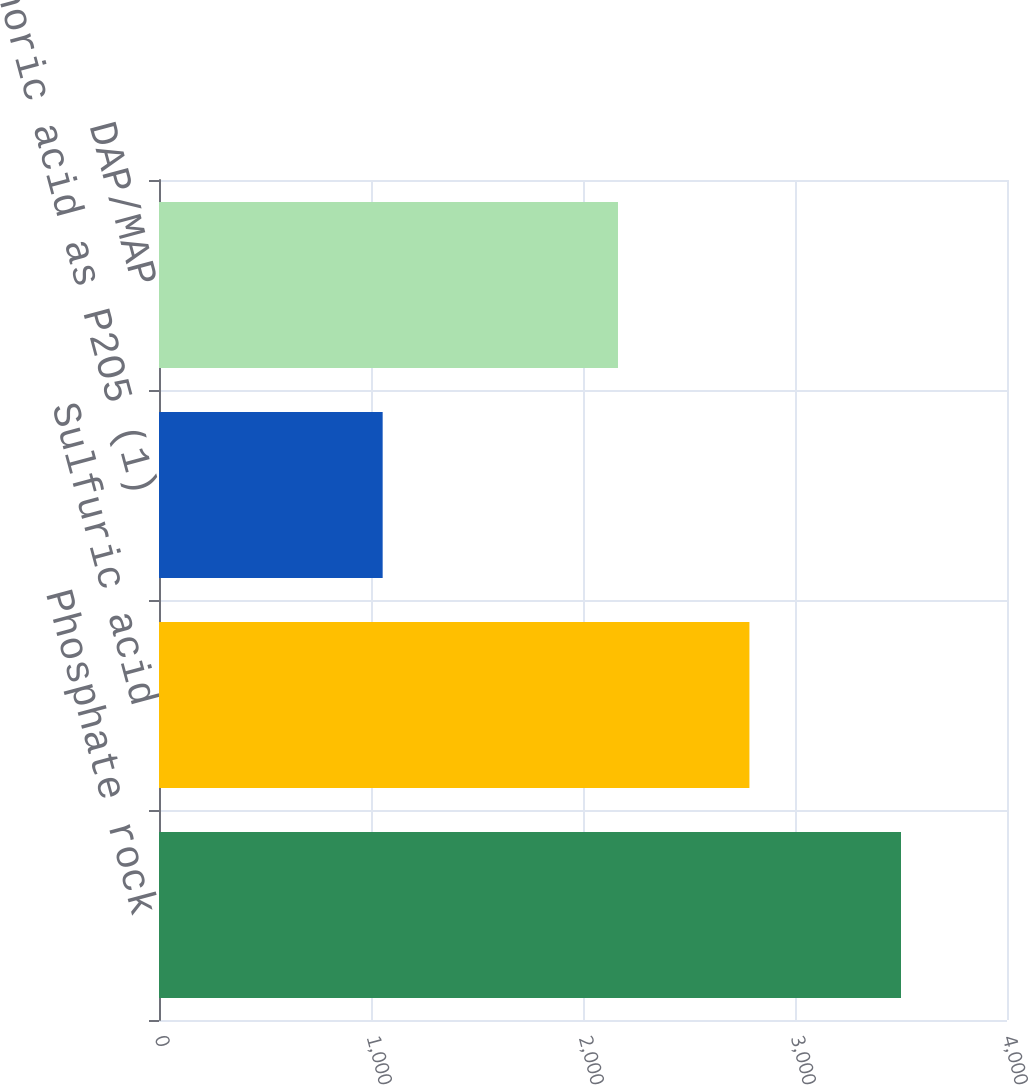Convert chart. <chart><loc_0><loc_0><loc_500><loc_500><bar_chart><fcel>Phosphate rock<fcel>Sulfuric acid<fcel>Phosphoric acid as P2O5 (1)<fcel>DAP/MAP<nl><fcel>3500<fcel>2785<fcel>1055<fcel>2165<nl></chart> 